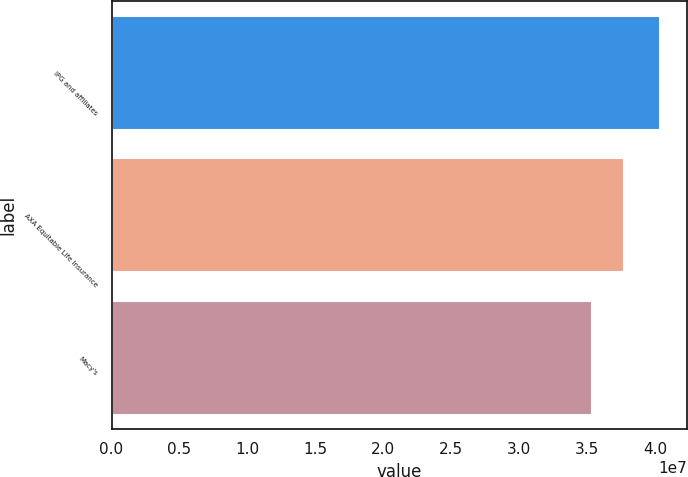Convert chart. <chart><loc_0><loc_0><loc_500><loc_500><bar_chart><fcel>IPG and affiliates<fcel>AXA Equitable Life Insurance<fcel>Macy's<nl><fcel>4.0327e+07<fcel>3.7725e+07<fcel>3.5337e+07<nl></chart> 